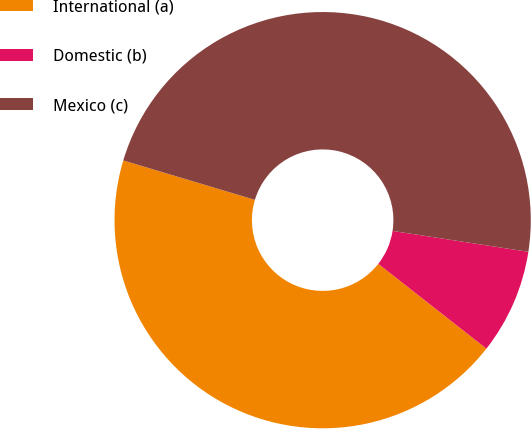Convert chart. <chart><loc_0><loc_0><loc_500><loc_500><pie_chart><fcel>International (a)<fcel>Domestic (b)<fcel>Mexico (c)<nl><fcel>44.05%<fcel>8.16%<fcel>47.8%<nl></chart> 